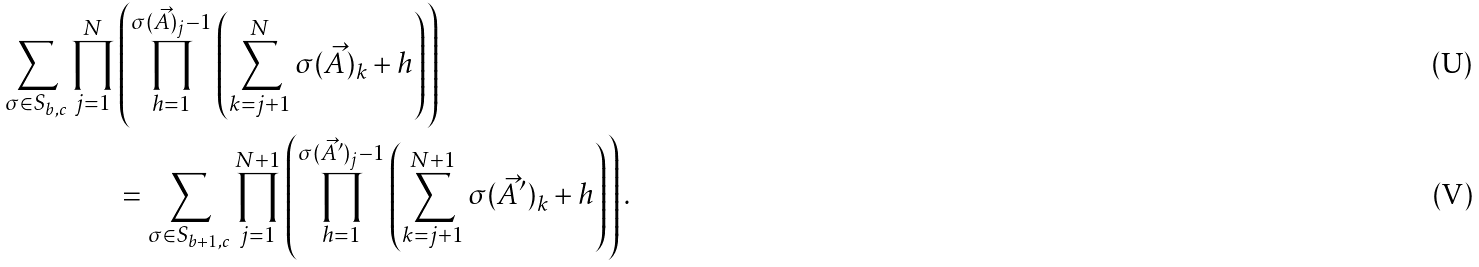<formula> <loc_0><loc_0><loc_500><loc_500>\sum _ { \sigma \in S _ { b , c } } \prod _ { j = 1 } ^ { N } & \left ( \prod _ { h = 1 } ^ { \sigma ( \vec { A } ) _ { j } - 1 } \left ( \sum _ { k = j + 1 } ^ { N } \sigma ( \vec { A } ) _ { k } + h \right ) \right ) \\ & = \sum _ { \sigma \in S _ { b + 1 , c } } \prod _ { j = 1 } ^ { N + 1 } \left ( \prod _ { h = 1 } ^ { \sigma ( \vec { A } ^ { \prime } ) _ { j } - 1 } \left ( \sum _ { k = j + 1 } ^ { N + 1 } \sigma ( \vec { A } ^ { \prime } ) _ { k } + h \right ) \right ) .</formula> 